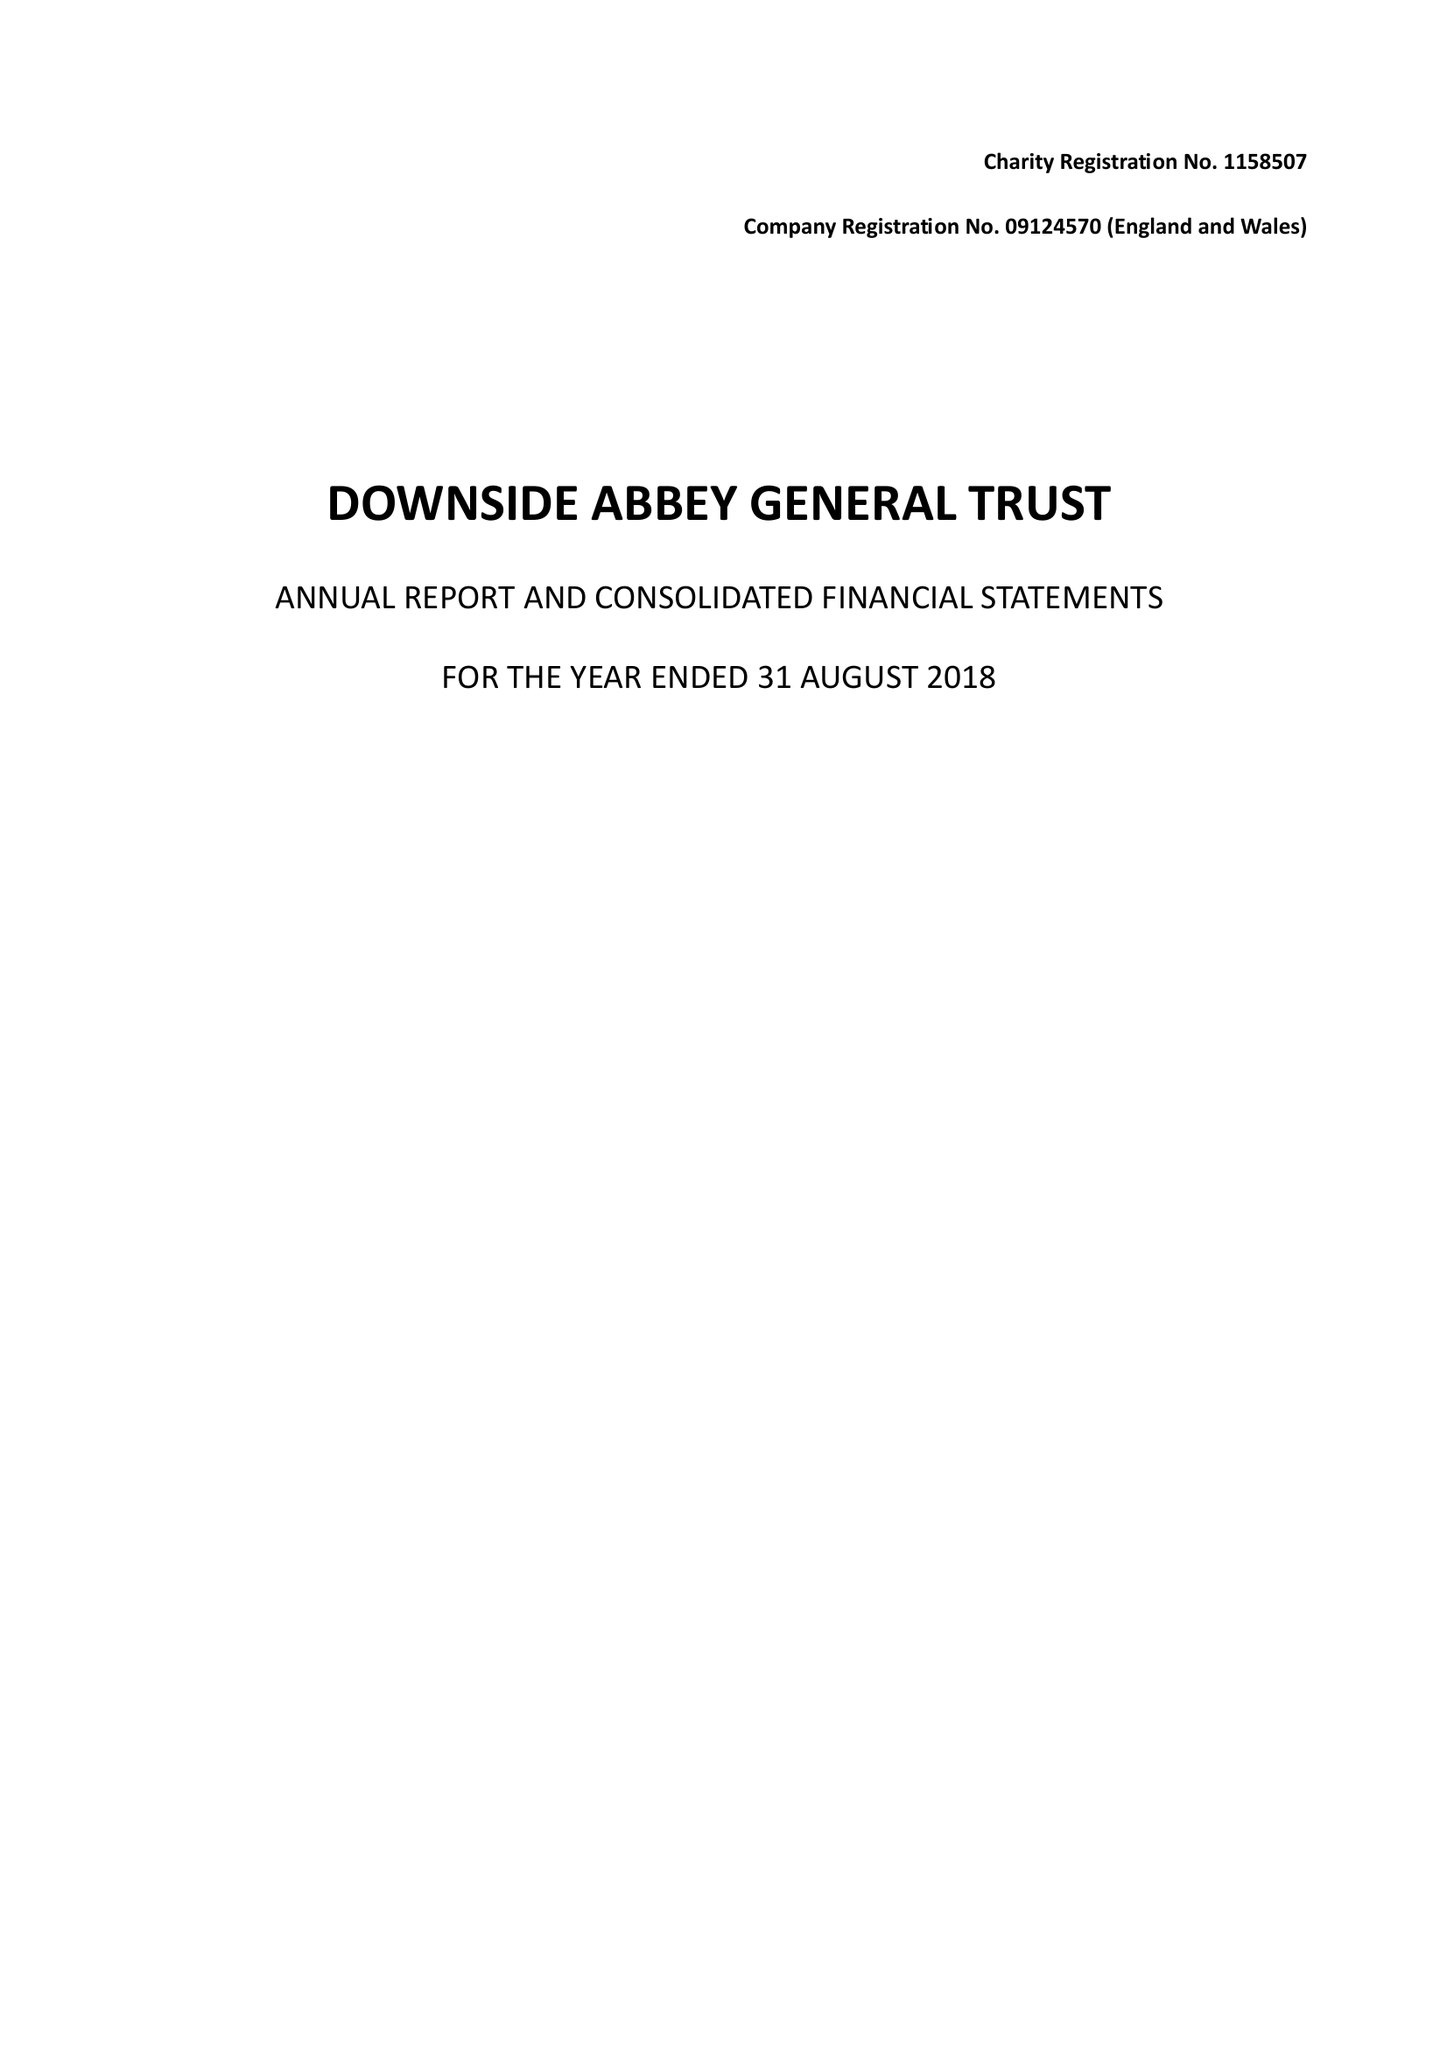What is the value for the address__post_town?
Answer the question using a single word or phrase. RADSTOCK 